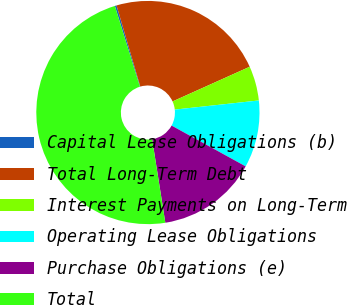<chart> <loc_0><loc_0><loc_500><loc_500><pie_chart><fcel>Capital Lease Obligations (b)<fcel>Total Long-Term Debt<fcel>Interest Payments on Long-Term<fcel>Operating Lease Obligations<fcel>Purchase Obligations (e)<fcel>Total<nl><fcel>0.25%<fcel>22.81%<fcel>5.0%<fcel>9.74%<fcel>14.49%<fcel>47.71%<nl></chart> 